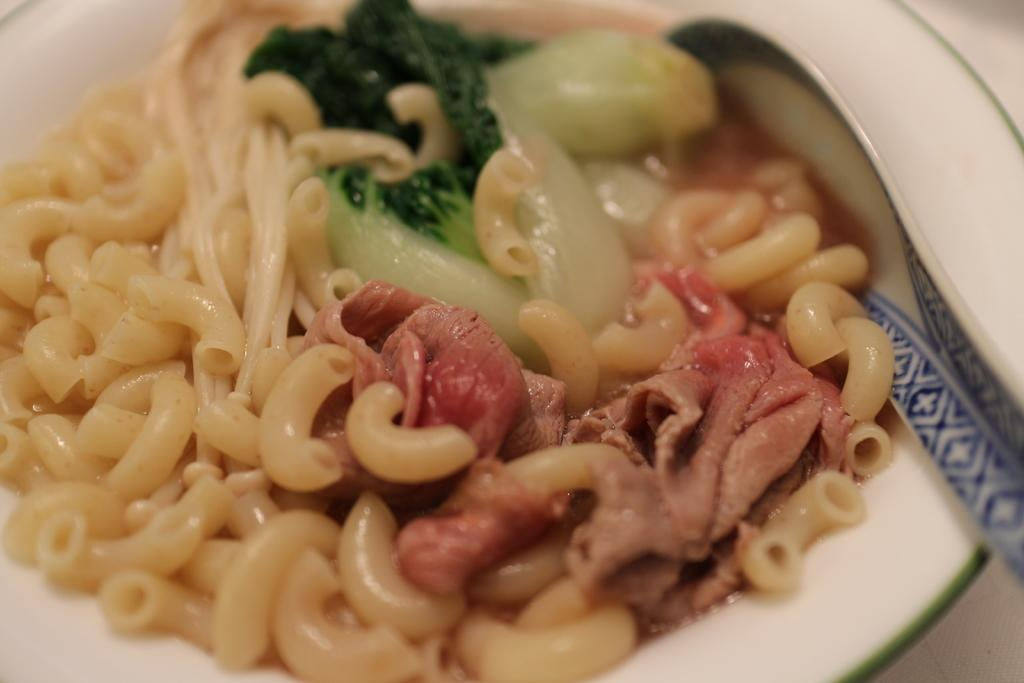What is present on the plate in the image? There is a plate in the image, and it contains a spoon. What type of food is on the plate? The plate contains a food item with pastas and noodles. What other ingredients are included in the food item? The food item includes meat. Are there any other components in the food item? Yes, there are other items in the food item. What type of station is visible in the image? There is no station present in the image. What is the current status of the food item in the image? The food item is stationary on the plate, but there is no information about its current status in terms of temperature or freshness. 